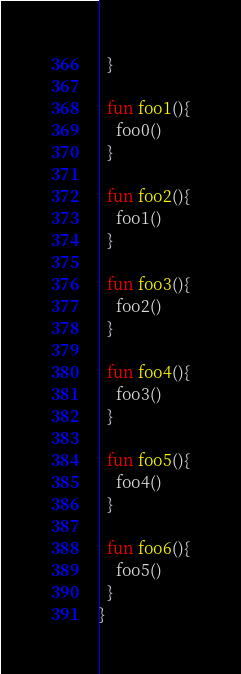<code> <loc_0><loc_0><loc_500><loc_500><_Kotlin_>  }

  fun foo1(){
    foo0()
  }

  fun foo2(){
    foo1()
  }

  fun foo3(){
    foo2()
  }

  fun foo4(){
    foo3()
  }

  fun foo5(){
    foo4()
  }

  fun foo6(){
    foo5()
  }
}</code> 